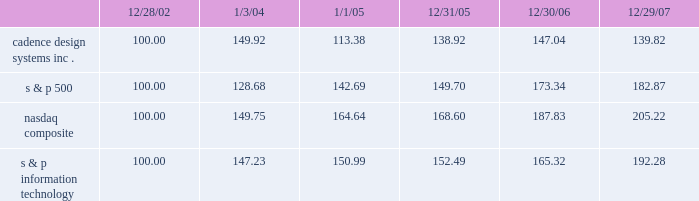The graph below matches cadence design systems , inc . 2019s cumulative 5-year total shareholder return on common stock with the cumulative total returns of the s&p 500 index , the s&p information technology index , and the nasdaq composite index .
The graph assumes that the value of the investment in our common stock , and in each index ( including reinvestment of dividends ) was $ 100 on december 28 , 2002 and tracks it through december 29 , 2007 .
Comparison of 5 year cumulative total return* among cadence design systems , inc. , the s&p 500 index , the nasdaq composite index and the s&p information technology index 12/29/0712/30/0612/31/051/1/051/3/0412/28/02 cadence design systems , inc .
Nasdaq composite s & p information technology s & p 500 * $ 100 invested on 12/28/02 in stock or on 12/31/02 in index-including reinvestment of dividends .
Indexes calculated on month-end basis .
Copyright b7 2007 , standard & poor 2019s , a division of the mcgraw-hill companies , inc .
All rights reserved .
Www.researchdatagroup.com/s&p.htm .
The stock price performance included in this graph is not necessarily indicative of future stock price performance .
What is the roi of an investment in s&p500 from 2006 to 2007? 
Computations: ((182.87 - 173.34) / 173.34)
Answer: 0.05498. 